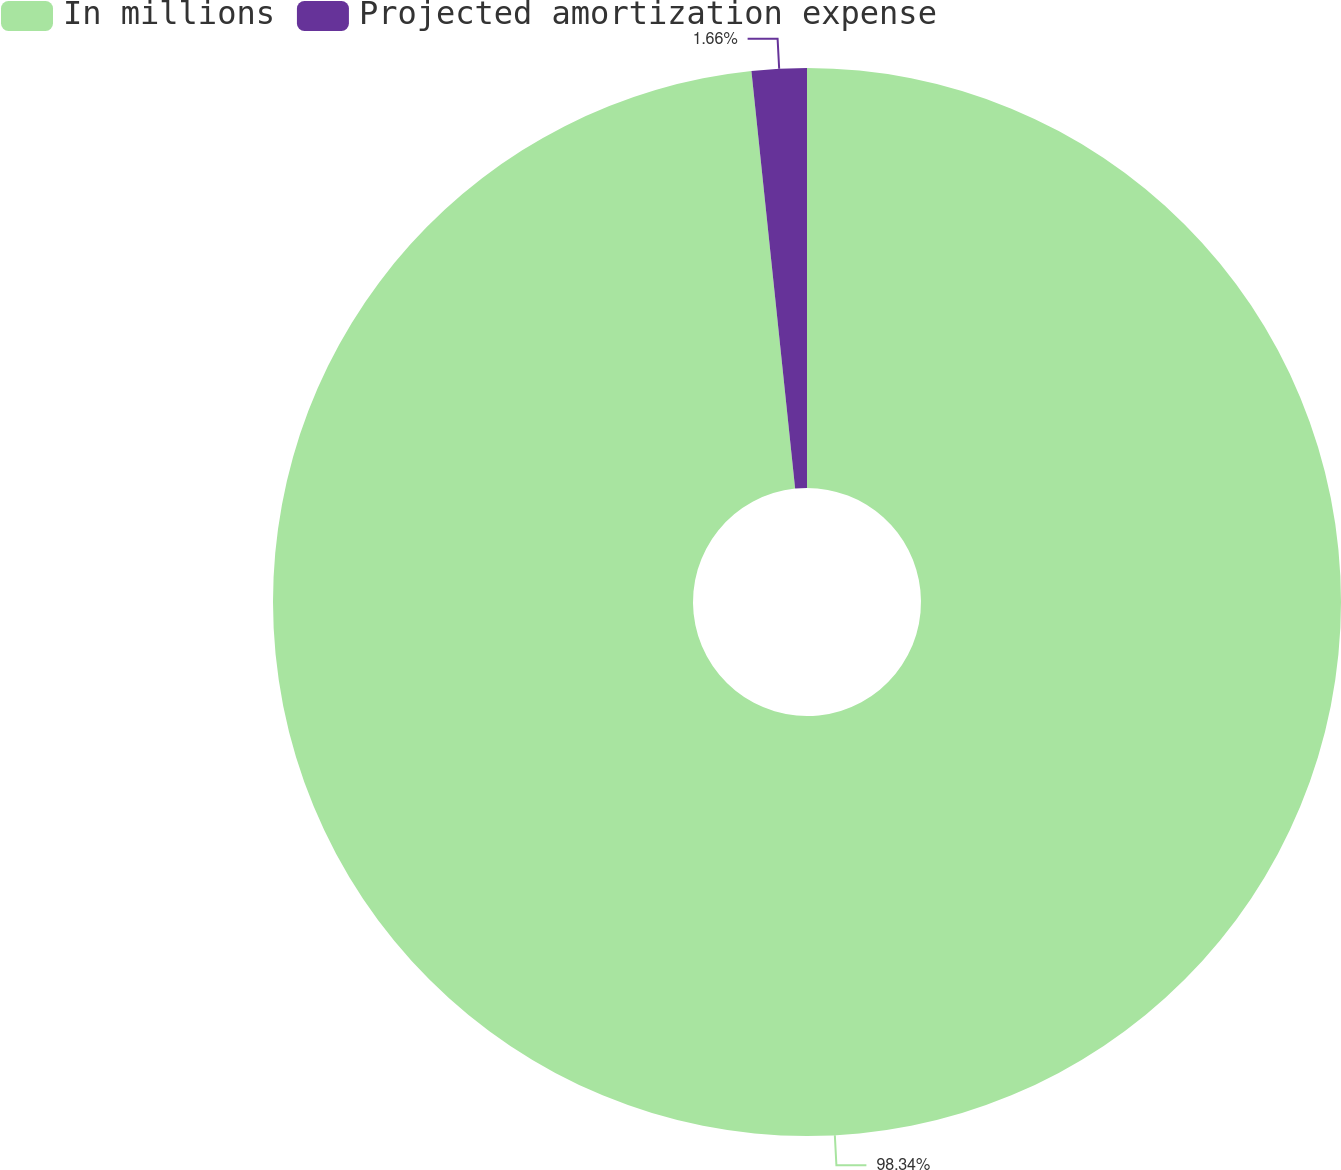<chart> <loc_0><loc_0><loc_500><loc_500><pie_chart><fcel>In millions<fcel>Projected amortization expense<nl><fcel>98.34%<fcel>1.66%<nl></chart> 